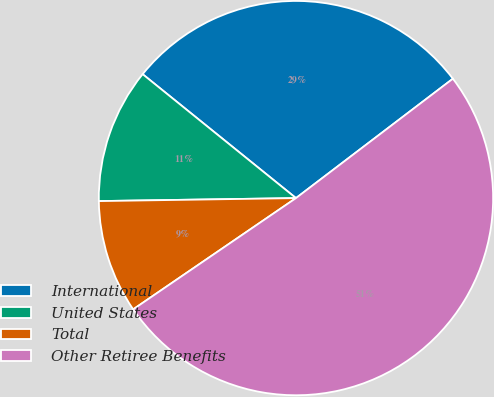Convert chart to OTSL. <chart><loc_0><loc_0><loc_500><loc_500><pie_chart><fcel>International<fcel>United States<fcel>Total<fcel>Other Retiree Benefits<nl><fcel>28.83%<fcel>11.06%<fcel>9.3%<fcel>50.81%<nl></chart> 